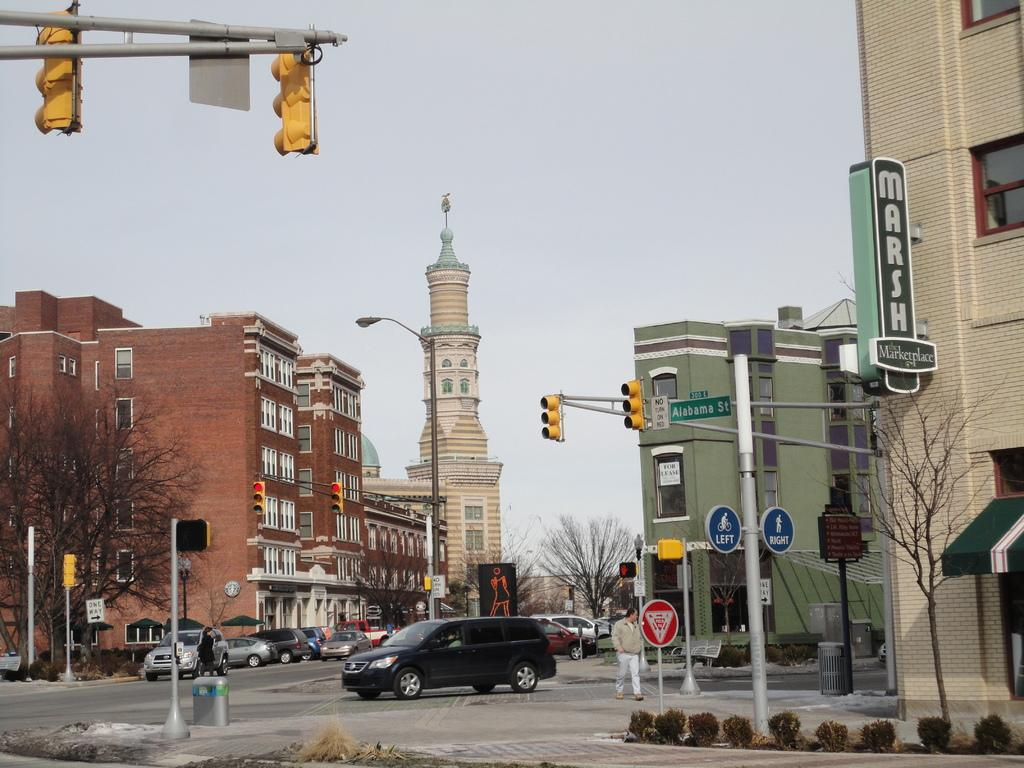<image>
Present a compact description of the photo's key features. A street with a sign for Marsh Marketplace. 